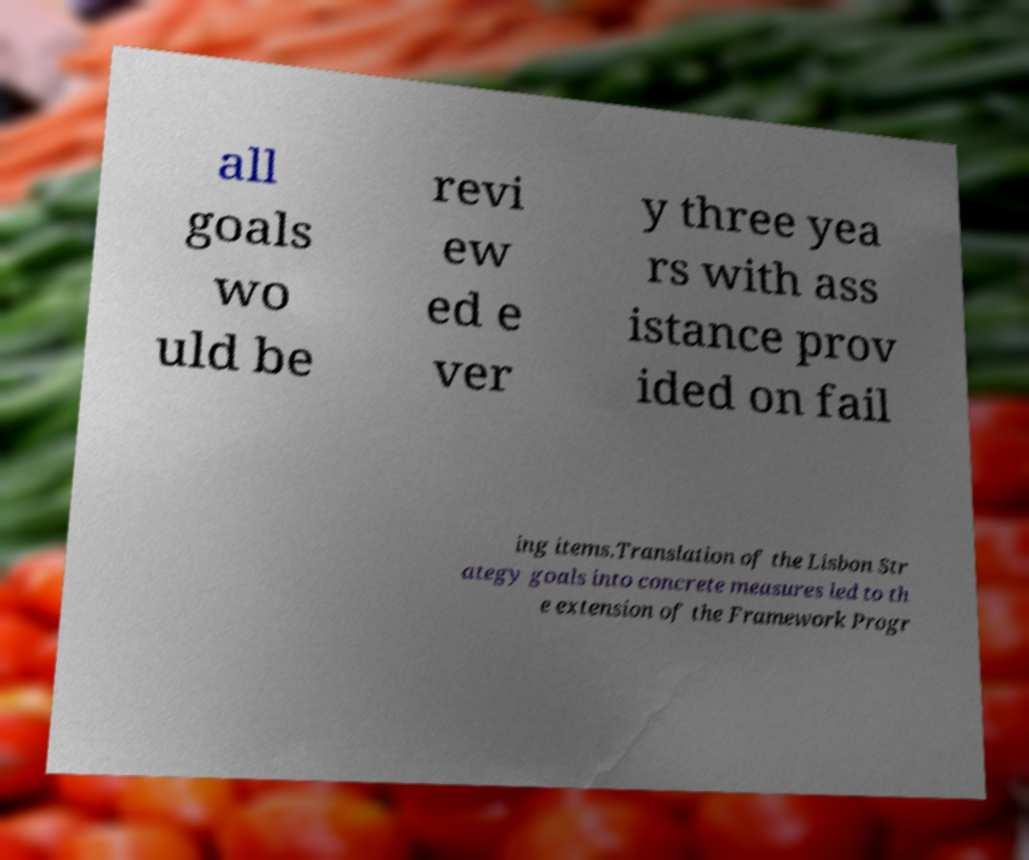Can you accurately transcribe the text from the provided image for me? all goals wo uld be revi ew ed e ver y three yea rs with ass istance prov ided on fail ing items.Translation of the Lisbon Str ategy goals into concrete measures led to th e extension of the Framework Progr 